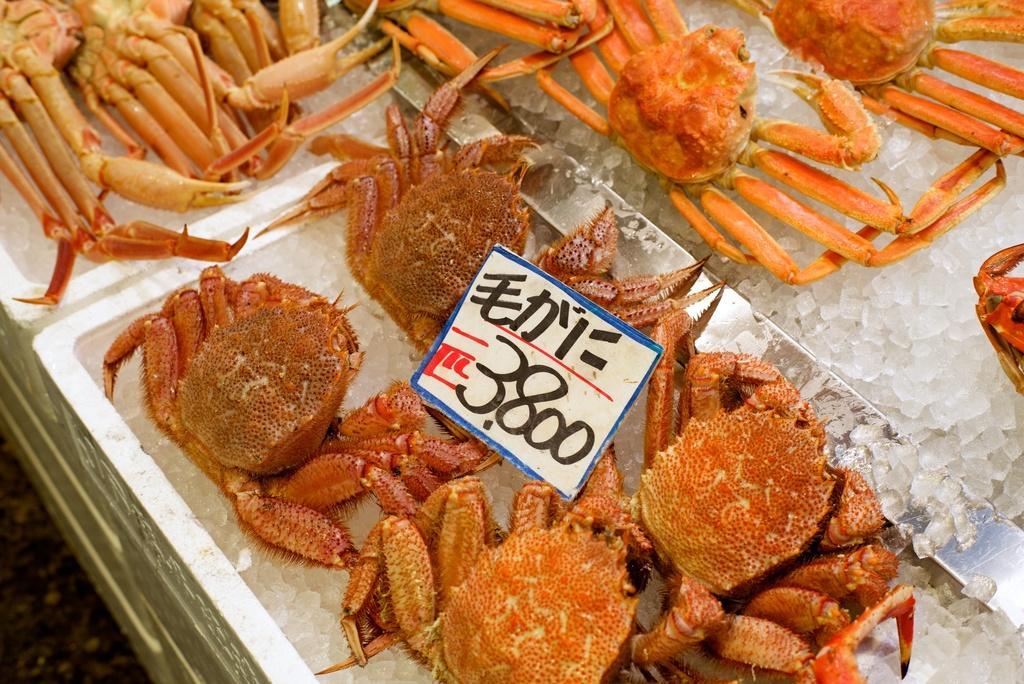Could you give a brief overview of what you see in this image? In this image we can see the grabs in the ice boxes and we can see the sticker with text and numbers. 